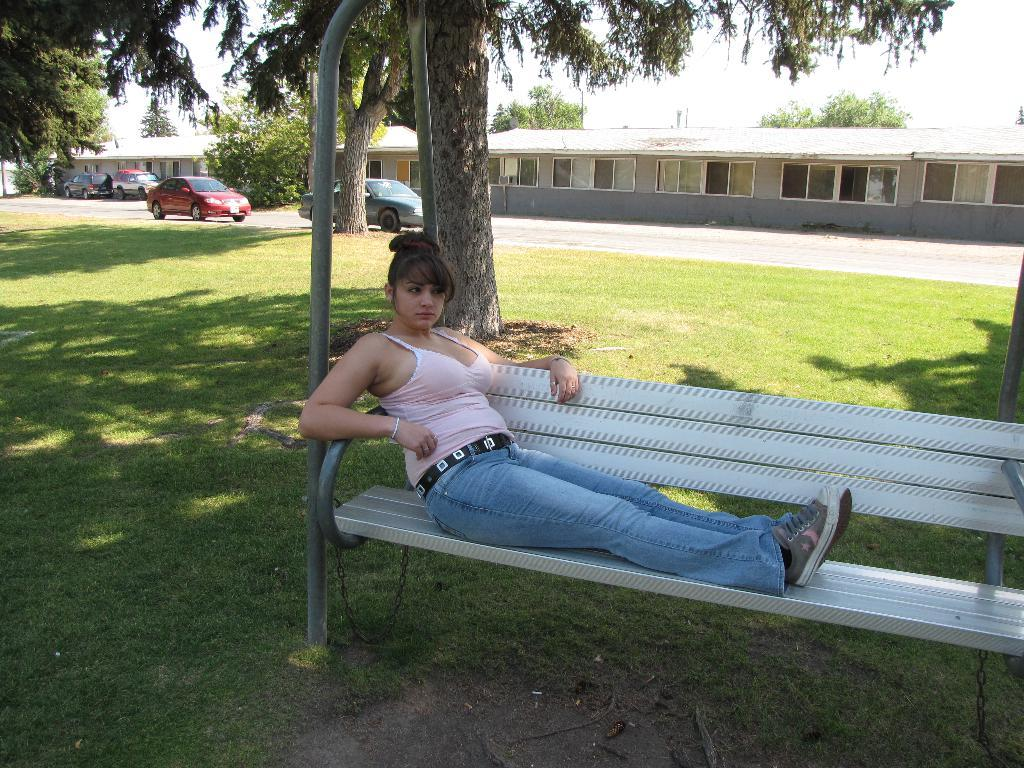What is the woman in the image doing? The woman is sitting on a bench. What type of surface is the woman sitting on? There is a grass lawn in the image. What can be seen in the background of the image? There are trees, buildings, windows, and vehicles on the road visible in the background. What type of haircut does the sky have in the image? The sky does not have a haircut, as it is a natural element and not a living being. 